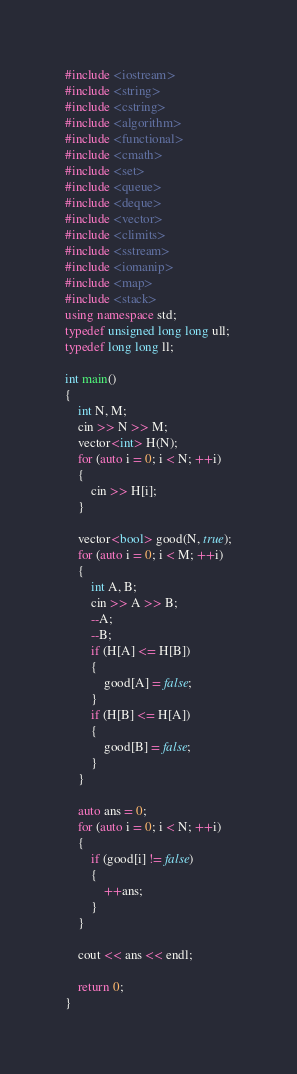Convert code to text. <code><loc_0><loc_0><loc_500><loc_500><_C++_>#include <iostream>
#include <string>
#include <cstring>
#include <algorithm>
#include <functional>
#include <cmath>
#include <set>
#include <queue>
#include <deque>
#include <vector>
#include <climits>
#include <sstream>
#include <iomanip>
#include <map>
#include <stack>
using namespace std;
typedef unsigned long long ull;
typedef long long ll;

int main()
{
	int N, M;
	cin >> N >> M;
	vector<int> H(N);
	for (auto i = 0; i < N; ++i)
	{
		cin >> H[i];
	}

	vector<bool> good(N, true);
	for (auto i = 0; i < M; ++i)
	{
		int A, B;
		cin >> A >> B;
		--A;
		--B;
		if (H[A] <= H[B])
		{
			good[A] = false;
		}
		if (H[B] <= H[A])
		{
			good[B] = false;
		}
	}

	auto ans = 0;
	for (auto i = 0; i < N; ++i)
	{
		if (good[i] != false)
		{
			++ans;
		}
	}

	cout << ans << endl;

	return 0;
}</code> 